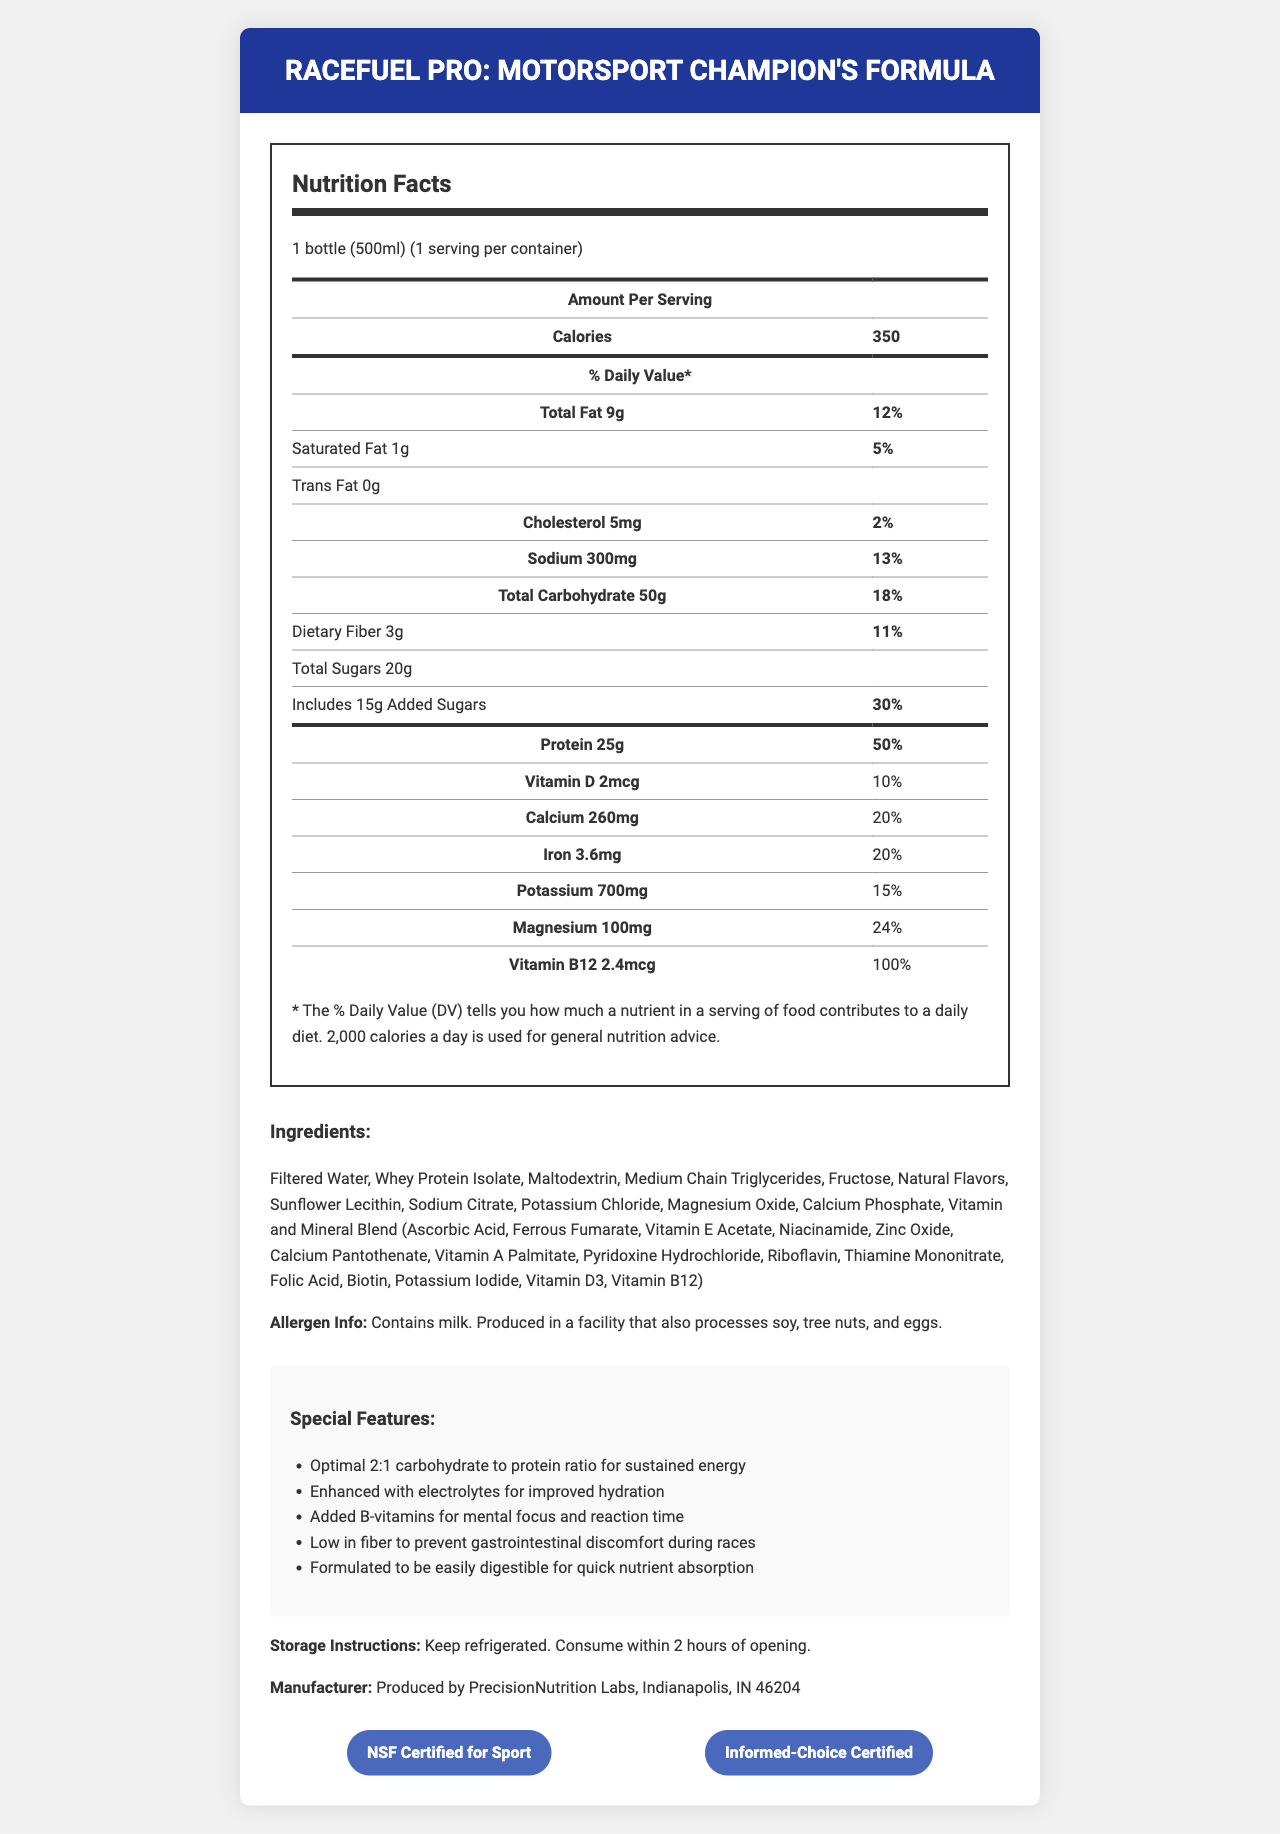What is the serving size of RaceFuel Pro? The serving size is listed at the top of the Nutrition Facts as "1 bottle (500ml)".
Answer: 1 bottle (500ml) How many calories are in one serving of RaceFuel Pro? The document states that there are 350 calories per serving.
Answer: 350 What is the total fat content, and what percentage of the daily value does it represent? The Nutrition Facts state that the total fat content is 9g, which represents 12% of the daily value.
Answer: 9g, 12% How much protein does RaceFuel Pro contain per serving? The document lists the protein content as 25g per serving.
Answer: 25g What percentage of the daily value of Vitamin B12 is provided by RaceFuel Pro? The Vitamin B12 content of 2.4mcg represents 100% of the daily value.
Answer: 100% What are the allergen warnings for RaceFuel Pro? The allergen information section specifically states the presence of milk and potential for cross-contamination with soy, tree nuts, and eggs.
Answer: Contains milk. Produced in a facility that also processes soy, tree nuts, and eggs. Which of the following is a feature of RaceFuel Pro? A. High in fiber B. Contains caffeine C. Enhanced with electrolytes D. Low in fat The document lists "Enhanced with electrolytes for improved hydration" as a special feature.
Answer: C Which vitamin is present in the highest percentage of daily value per serving? A. Vitamin D B. Vitamin B12 C. Calcium D. Magnesium Vitamin B12 provides 100% of the daily value, which is the highest among the listed vitamins and minerals.
Answer: B Is RaceFuel Pro gluten-free? The document does not mention anything about gluten content or whether the product is gluten-free.
Answer: Not enough information What storage instructions are given for RaceFuel Pro? The storage instructions state to keep the product refrigerated and consume it within 2 hours of opening.
Answer: Keep refrigerated. Consume within 2 hours of opening. Does RaceFuel Pro contain any added sugars? The Nutrition Facts state that the product contains 15g of added sugars, which represents 30% of the daily value.
Answer: Yes Summarize the main features of the RaceFuel Pro product. This explanation summarizes the key features, nutritional content, and additional information about RaceFuel Pro, providing a comprehensive overview.
Answer: RaceFuel Pro is a pre-race meal replacement shake designed for motorsport champions with a balanced macronutrient profile. It offers 350 calories per serving, including 25g of protein and 50g of carbohydrates in a 2:1 ratio. The product is enhanced with electrolytes, B-vitamins, and specific nutrients to support energy, hydration, mental focus, and quick nutrient absorption. The shake is low in fiber to avoid gastrointestinal issues during races. It is certified by NSF and Informed-Choice, contains milk, and is produced in a facility that processes other allergens. Storage instructions indicate refrigeration and consumption within 2 hours of opening. Who is the manufacturer of RaceFuel Pro? The manufacturer information section at the bottom of the document states that PrecisionNutrition Labs produces RaceFuel Pro.
Answer: PrecisionNutrition Labs, Indianapolis, IN 46204 